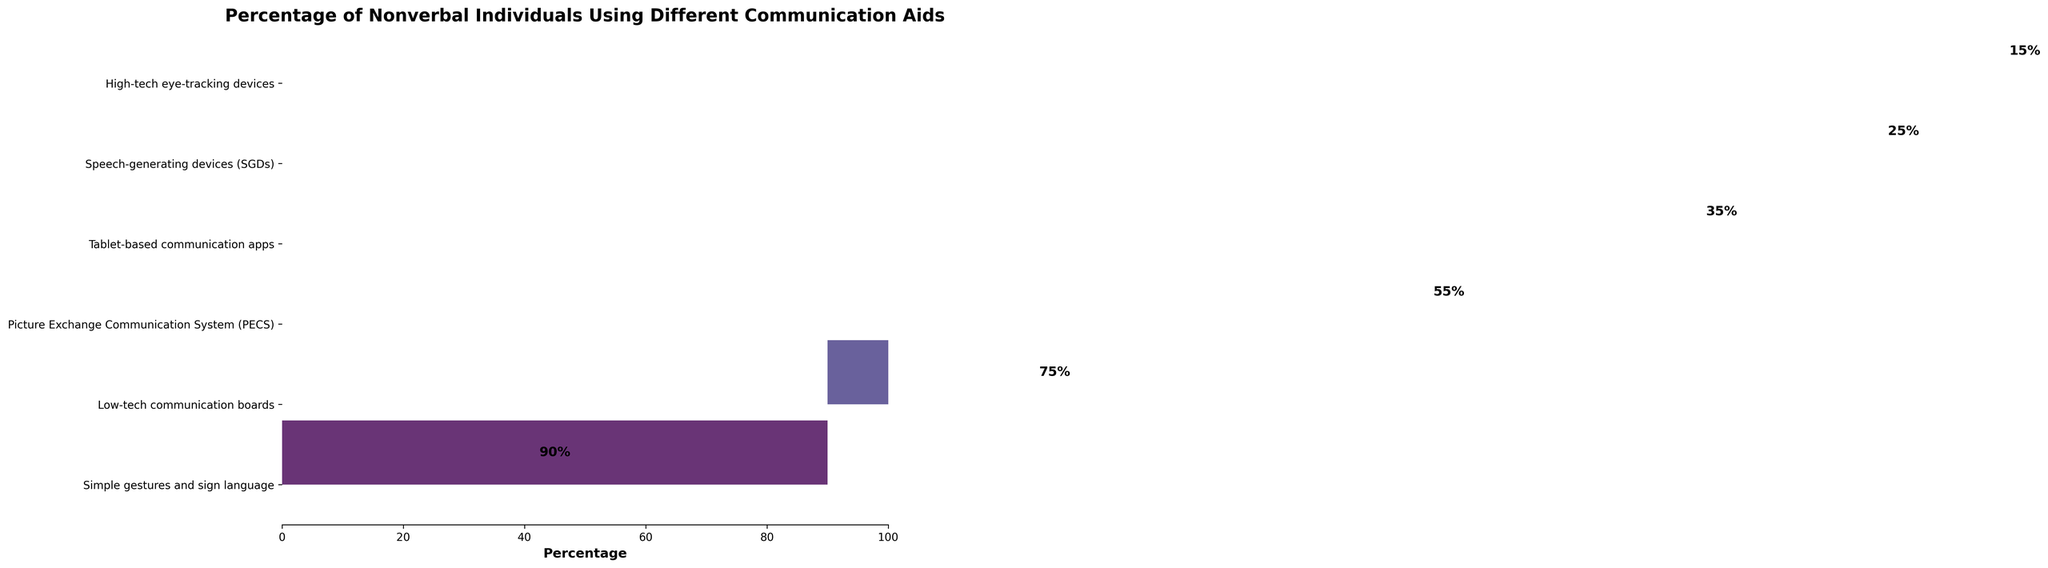What is the title of the funnel chart? The title is usually found at the top of the chart. This one states the chart's main subject.
Answer: Percentage of Nonverbal Individuals Using Different Communication Aids Which communication aid has the highest usage percentage? By looking at the top segment of the funnel and checking the labels, we can identify the aid with the highest percentage.
Answer: Simple gestures and sign language What is the usage percentage of Speech-generating devices (SGDs)? Locate the Speech-generating devices (SGDs) segment and read the percentage value shown within that section.
Answer: 25% Which communication aid has the lowest percentage? The smallest segment of the funnel, at the bottom of the chart, represents the communication aid with the lowest percentage.
Answer: High-tech eye-tracking devices How many communication aids are represented in the chart? Count the number of different segments in the funnel chart. Each segment represents a communication aid.
Answer: 6 What is the difference in usage percentage between Tablet-based communication apps and High-tech eye-tracking devices? Find the percentages for both Tablet-based communication apps (35%) and High-tech eye-tracking devices (15%). Then subtract the smaller percentage from the larger one: 35 - 15 = 20.
Answer: 20% Which two communication aids have the closest usage percentages? Compare the usage percentages of all communication aids to find the two closest values. Picture Exchange Communication System (PECS) at 55% and Tablet-based communication apps at 35% have a difference of 20 percentage points, which is the smallest gap compared to others.
Answer: Tablet-based communication apps and Picture Exchange Communication System (PECS) What is the combined percentage usage of the top three communication aids? Sum the usage percentages of Simple gestures and sign language (90%), Low-tech communication boards (75%), and Picture Exchange Communication System (PECS) (55%): 90 + 75 + 55 = 220.
Answer: 220% Which communication aid has a usage percentage greater than 50% but less than 80%? Identify the communication aids whose percentages fall within the specified range. Low-tech communication boards at 75% is the one that fits.
Answer: Low-tech communication boards Is the usage percentage of Picture Exchange Communication System (PECS) higher than that of Tablet-based communication apps? Compare the two percentages: PECS has 55% and Tablet-based communication apps have 35%. Since 55% is greater than 35%, the answer is yes.
Answer: Yes 